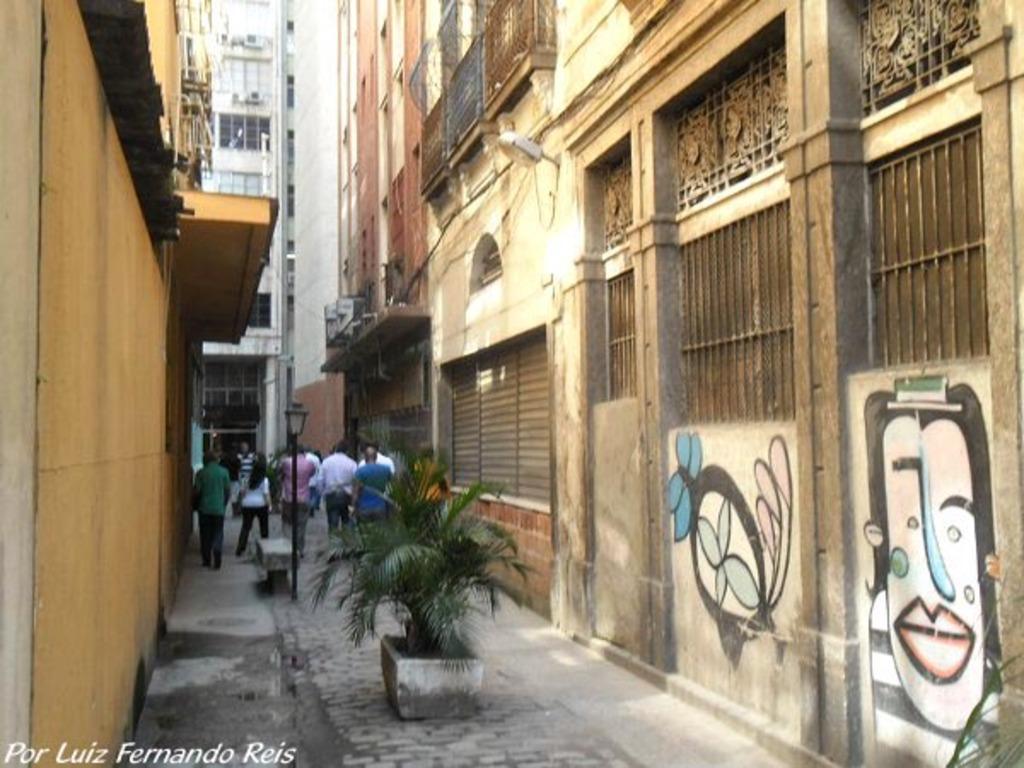Describe this image in one or two sentences. In this image we can see these people walking on the road, we can the flower pots, light poles, buildings on either side and here we can see the watermark on the bottom left side of the image. 